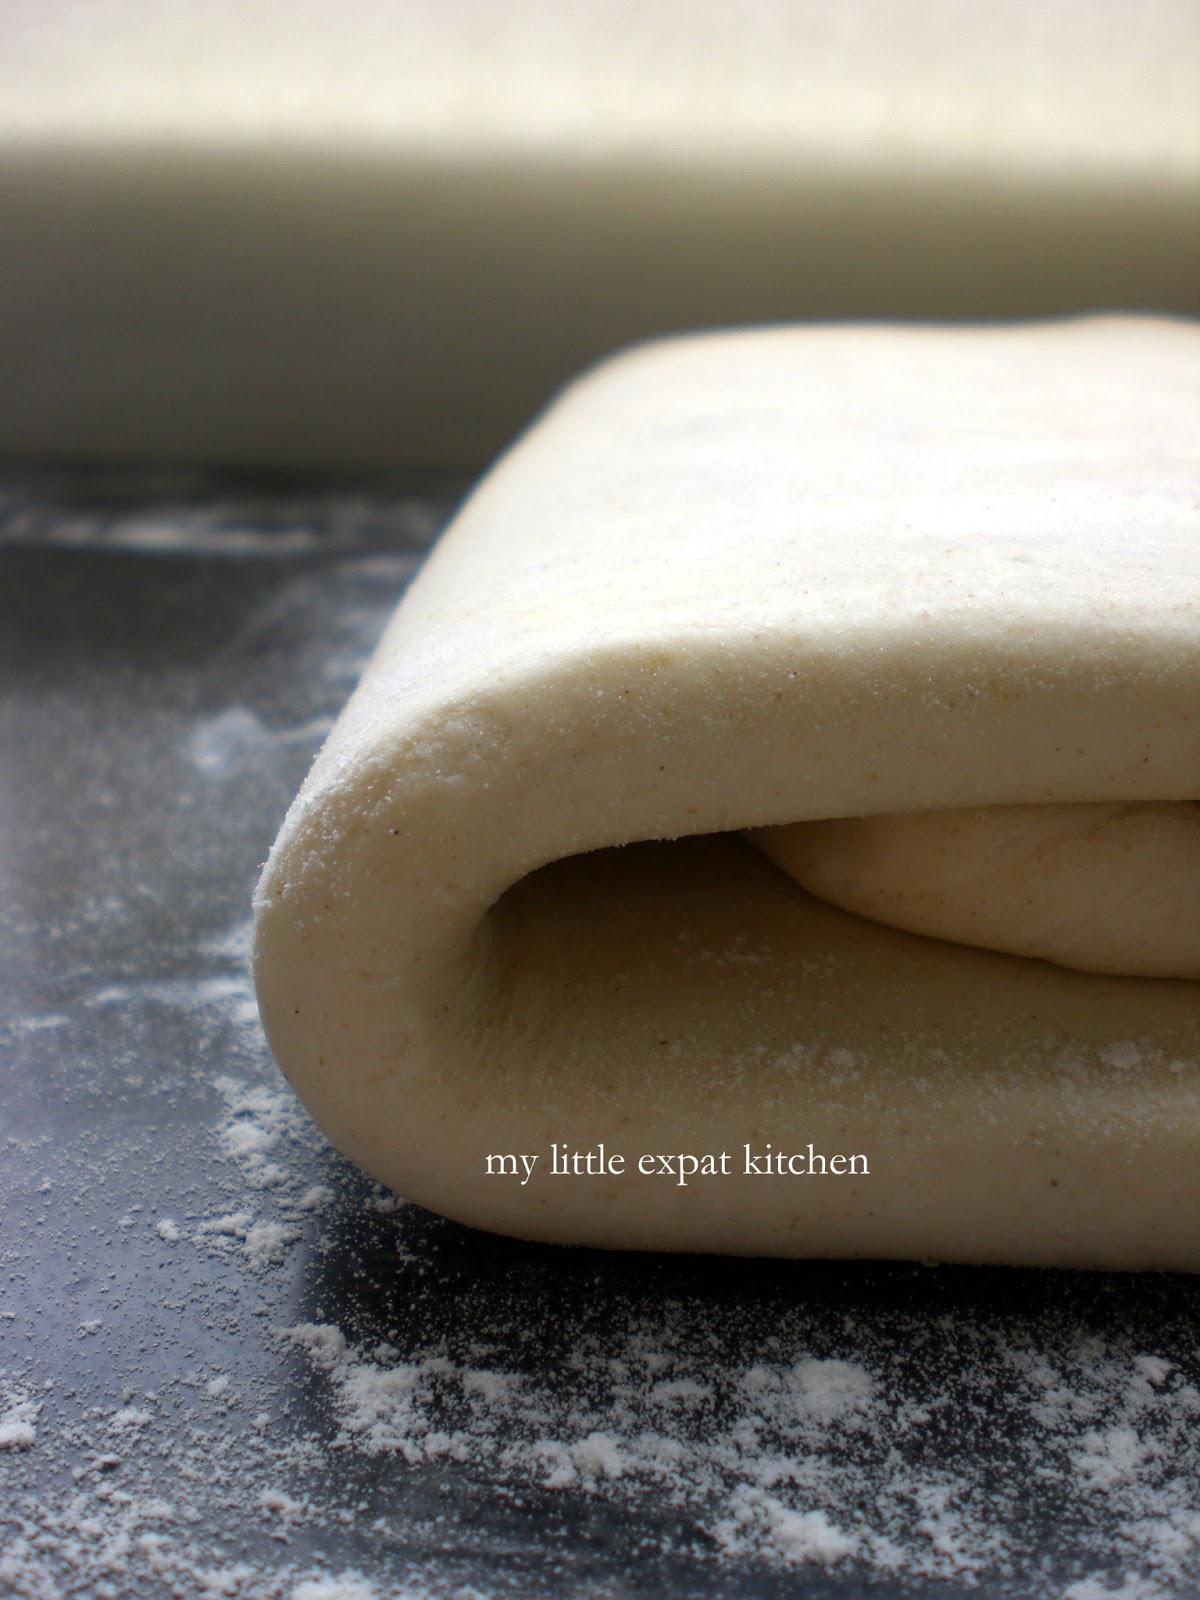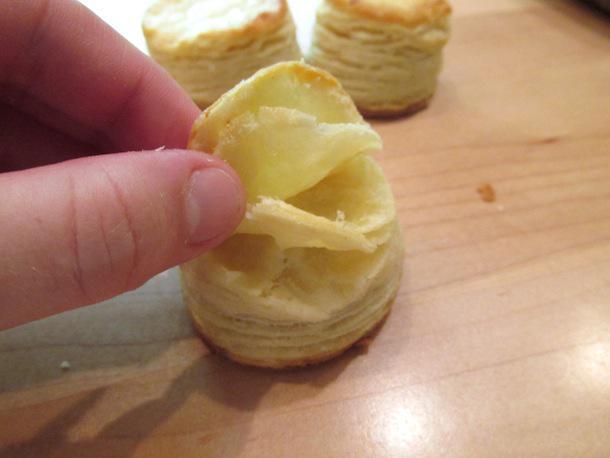The first image is the image on the left, the second image is the image on the right. For the images displayed, is the sentence "a piece of bread that is cut in half is showing all the layers and bubbles inside" factually correct? Answer yes or no. No. The first image is the image on the left, the second image is the image on the right. Given the left and right images, does the statement "A metal utinsil is near the baking ingredients in the image on the right." hold true? Answer yes or no. No. 